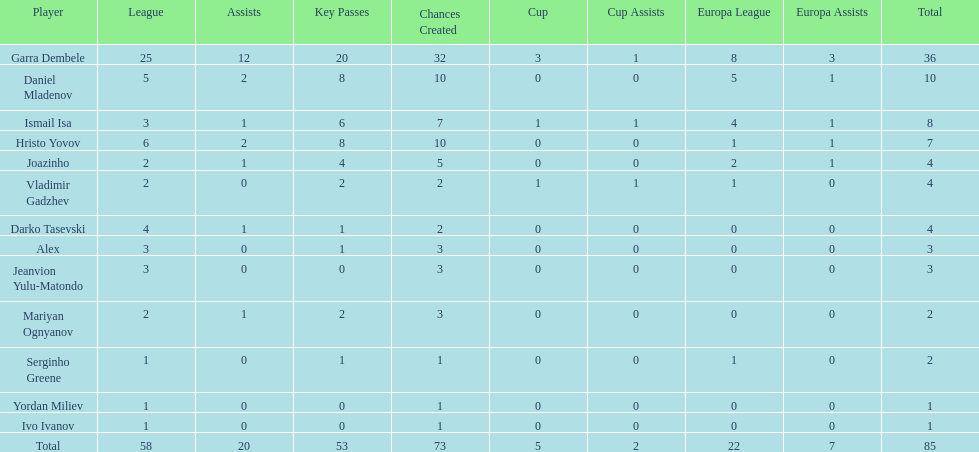Which players have at least 4 in the europa league? Garra Dembele, Daniel Mladenov, Ismail Isa. 